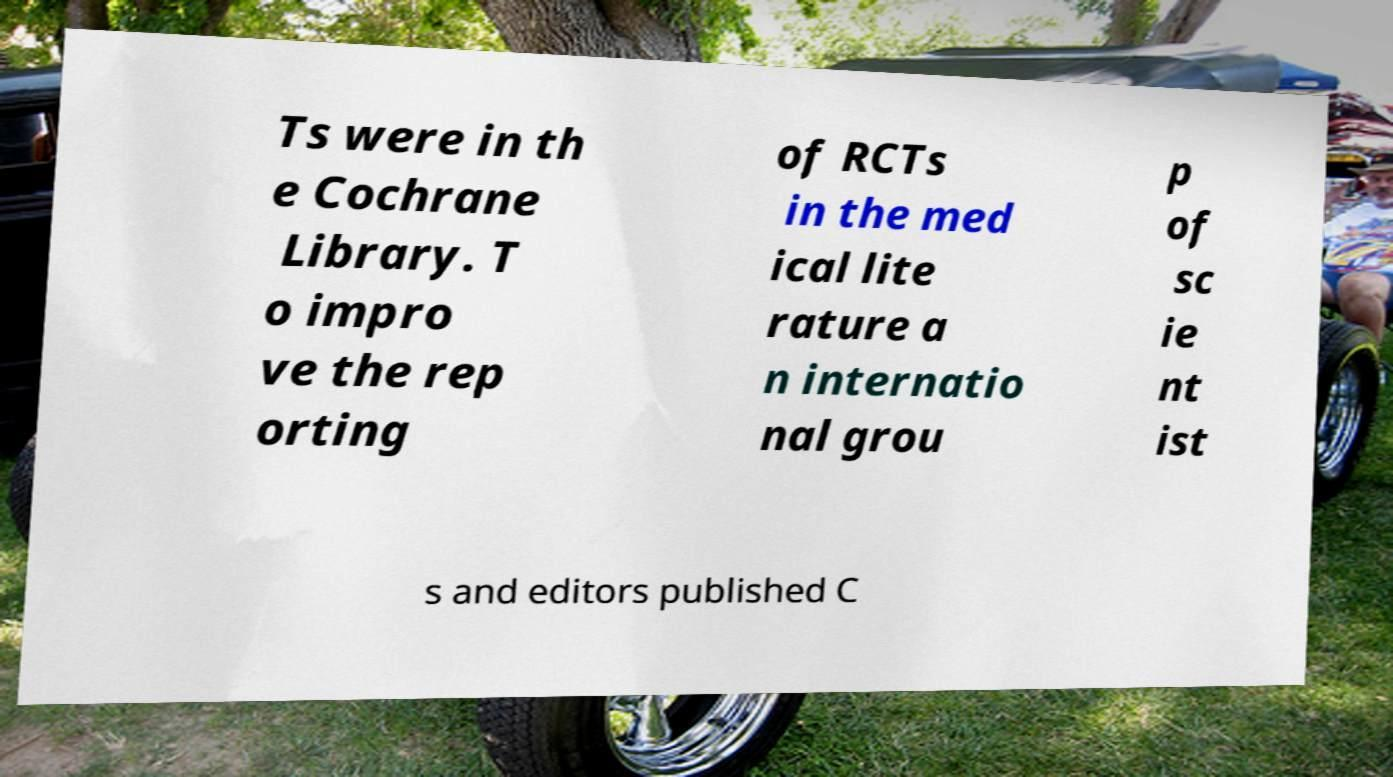Can you accurately transcribe the text from the provided image for me? Ts were in th e Cochrane Library. T o impro ve the rep orting of RCTs in the med ical lite rature a n internatio nal grou p of sc ie nt ist s and editors published C 